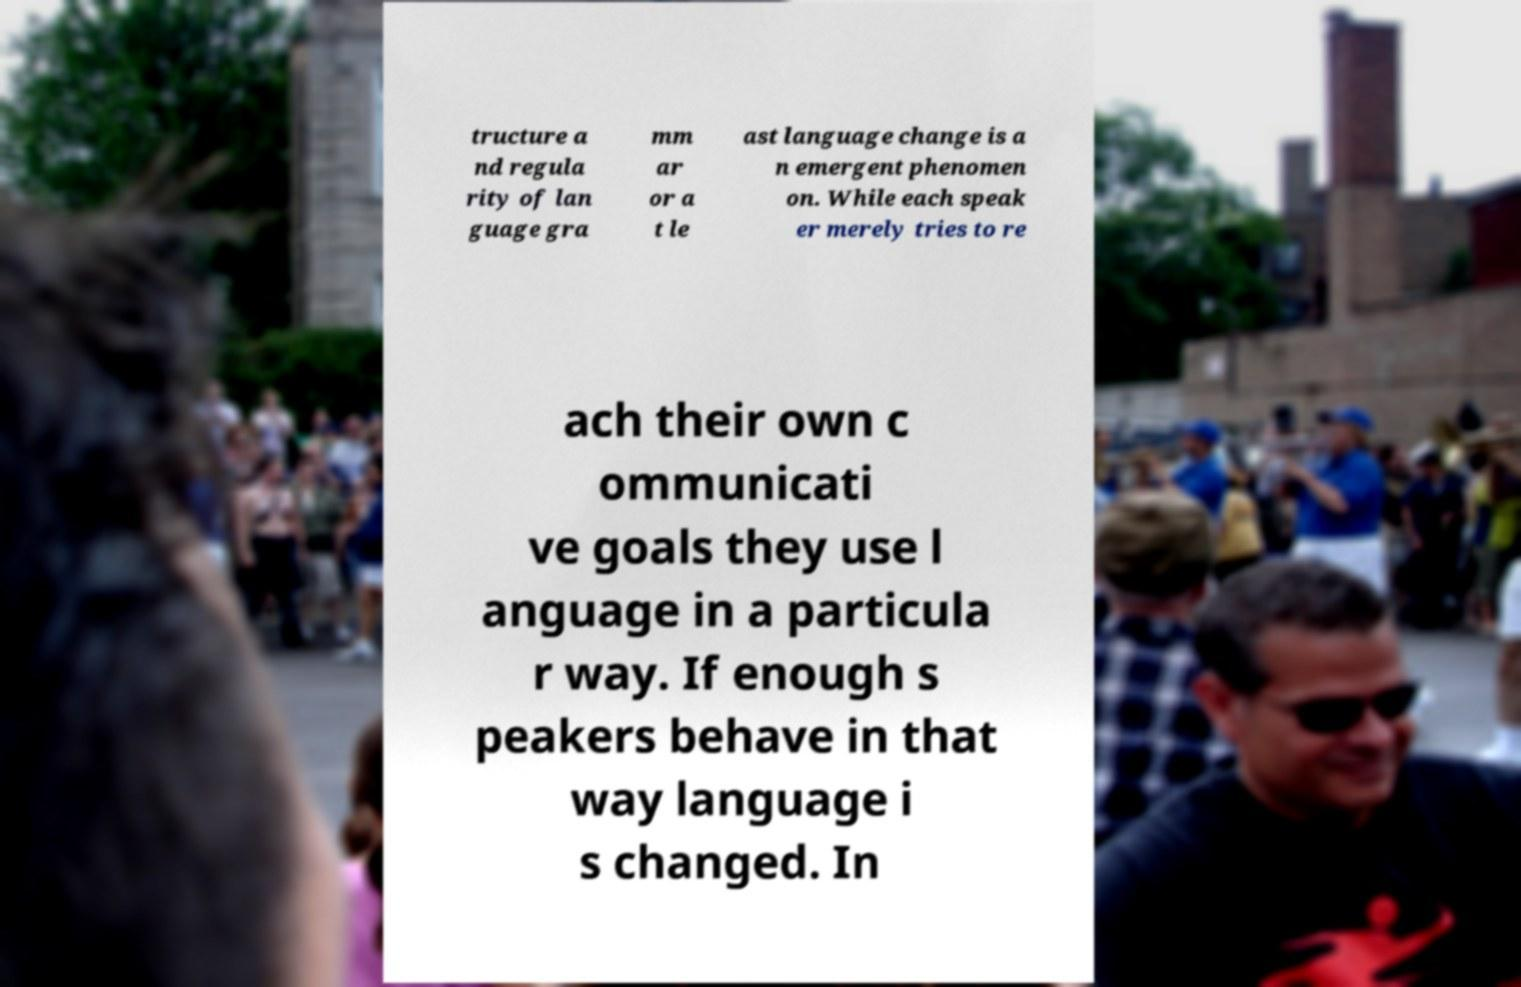What messages or text are displayed in this image? I need them in a readable, typed format. tructure a nd regula rity of lan guage gra mm ar or a t le ast language change is a n emergent phenomen on. While each speak er merely tries to re ach their own c ommunicati ve goals they use l anguage in a particula r way. If enough s peakers behave in that way language i s changed. In 